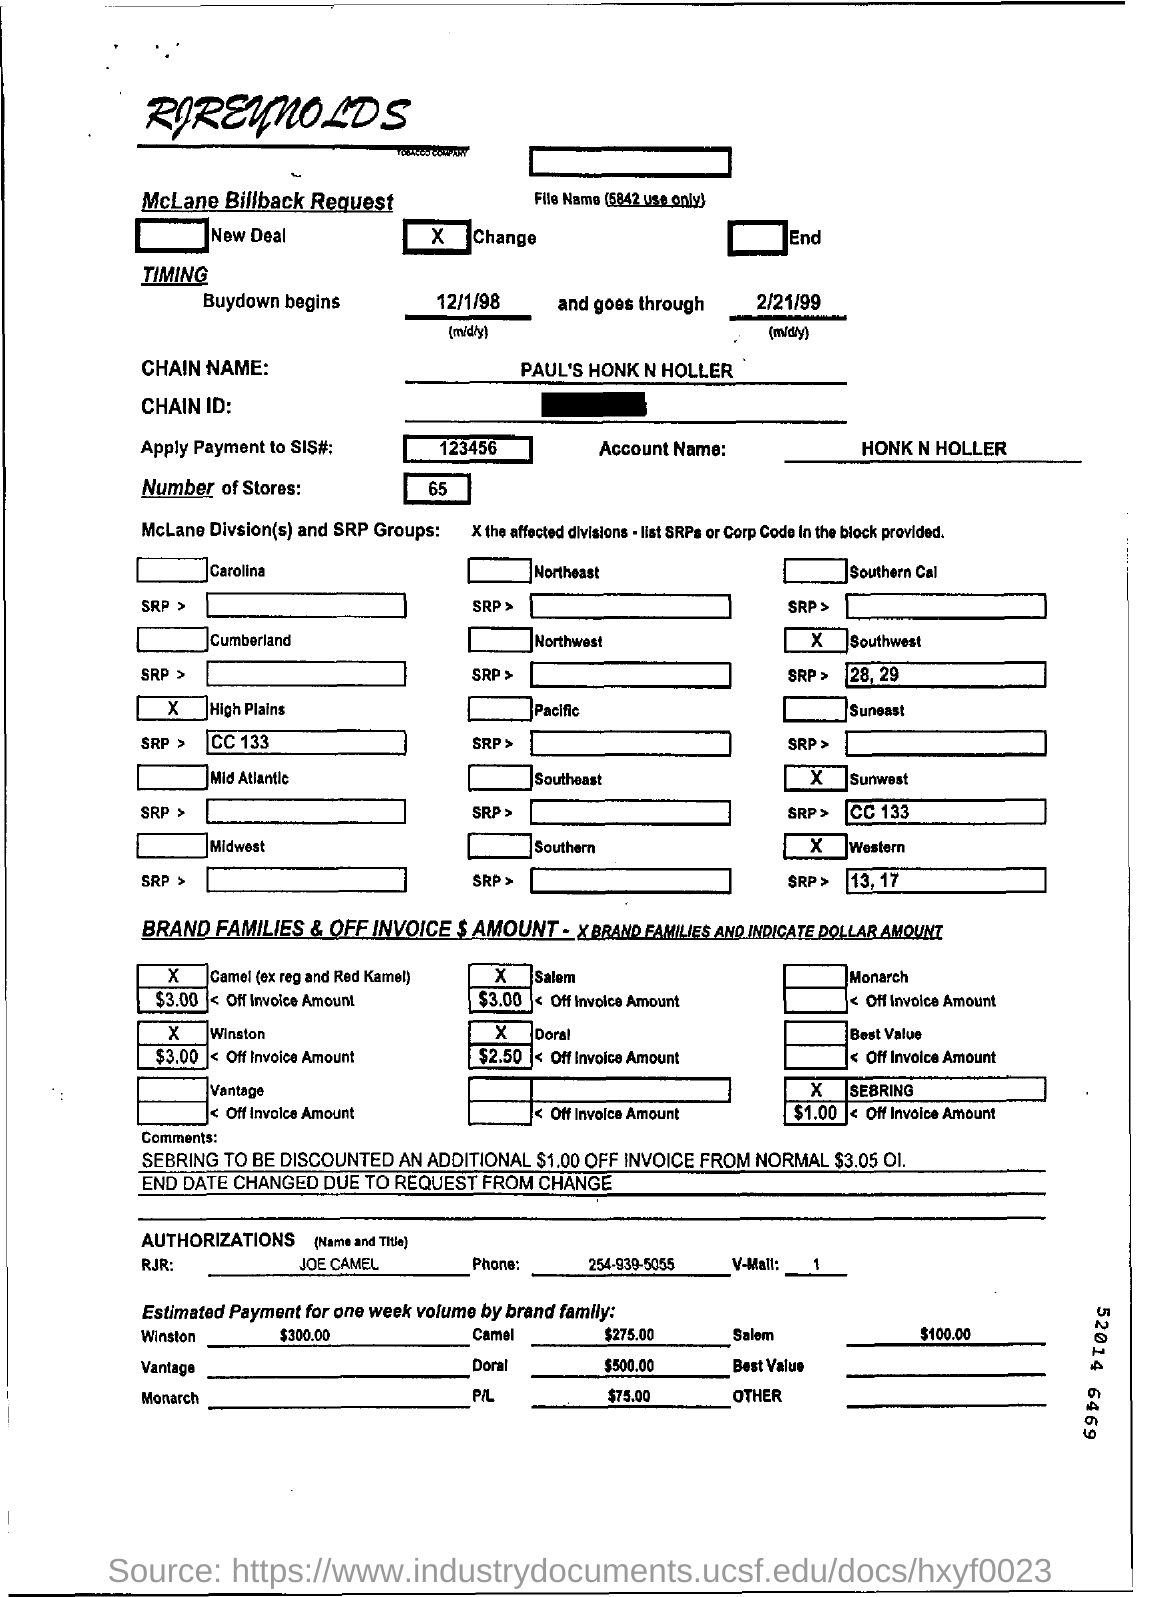Outline some significant characteristics in this image. There are approximately 65 stores. The chain name is Paul's Honk and Hollar. The account mentions the name "HONK N HOLLER". 